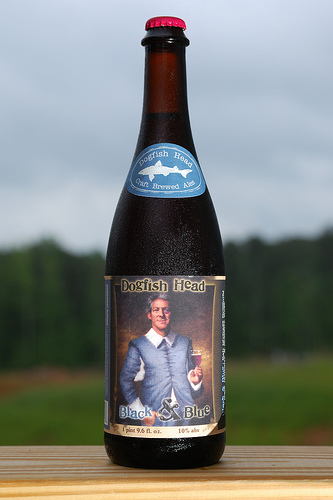<image>
Can you confirm if the shark sticker is on the bottle? Yes. Looking at the image, I can see the shark sticker is positioned on top of the bottle, with the bottle providing support. Where is the trees in relation to the field? Is it in front of the field? No. The trees is not in front of the field. The spatial positioning shows a different relationship between these objects. 